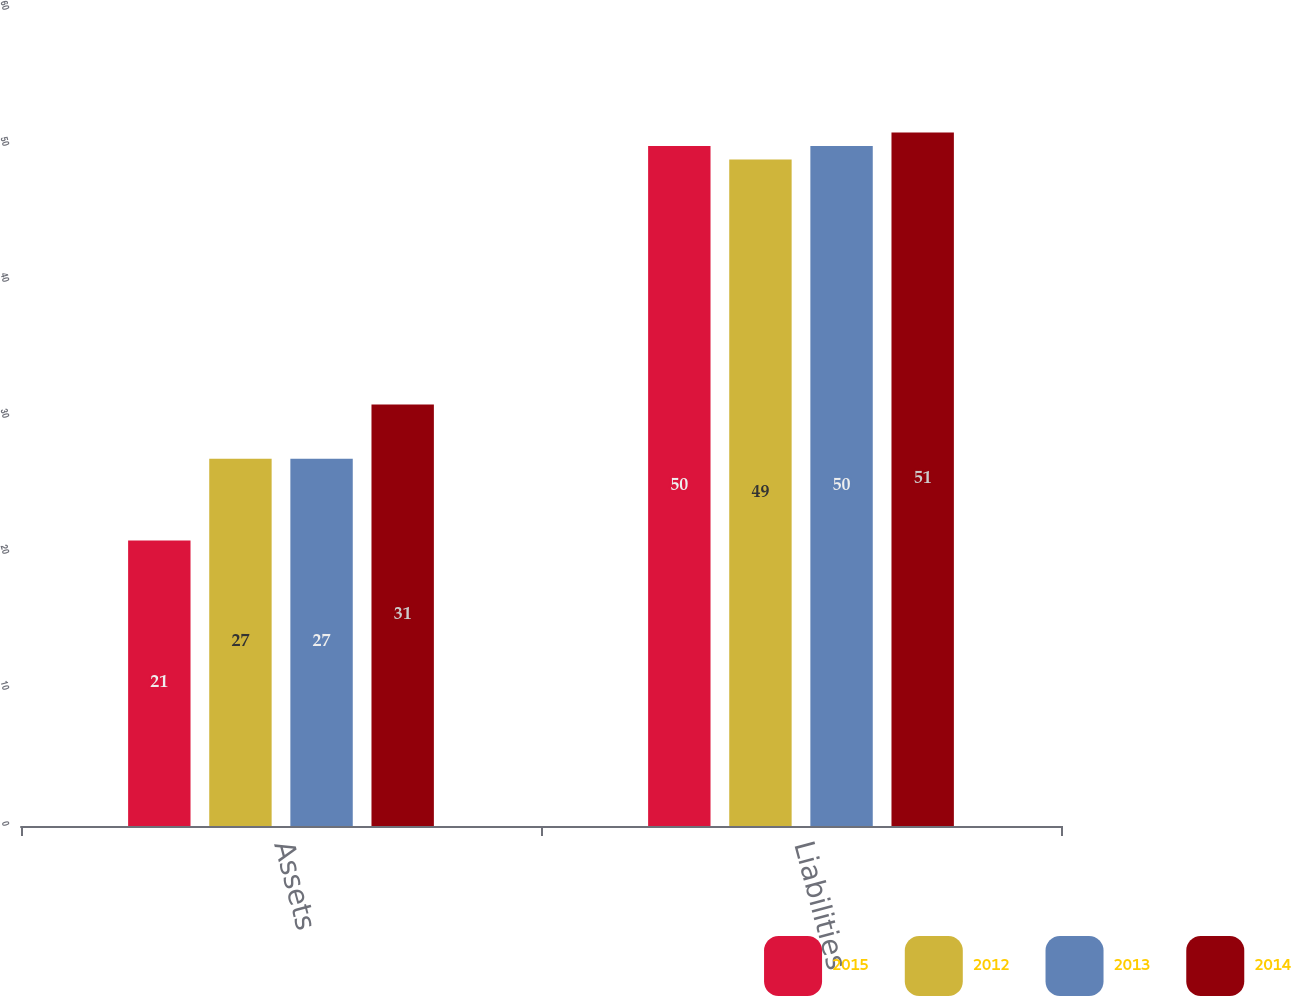Convert chart. <chart><loc_0><loc_0><loc_500><loc_500><stacked_bar_chart><ecel><fcel>Assets<fcel>Liabilities<nl><fcel>2015<fcel>21<fcel>50<nl><fcel>2012<fcel>27<fcel>49<nl><fcel>2013<fcel>27<fcel>50<nl><fcel>2014<fcel>31<fcel>51<nl></chart> 